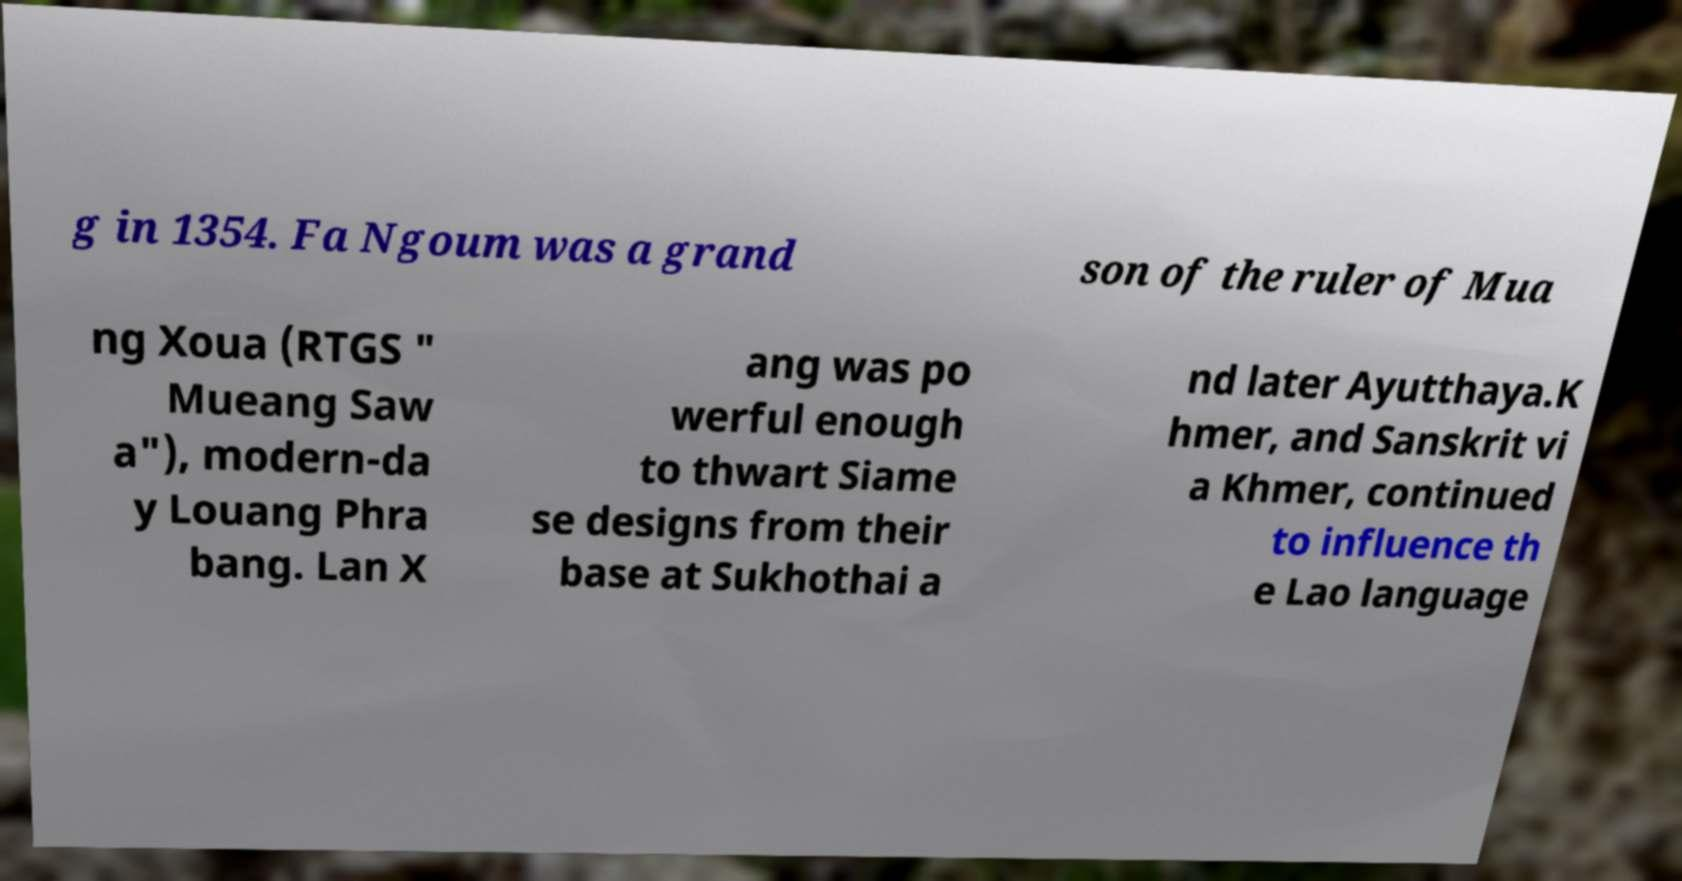Could you extract and type out the text from this image? g in 1354. Fa Ngoum was a grand son of the ruler of Mua ng Xoua (RTGS " Mueang Saw a"), modern-da y Louang Phra bang. Lan X ang was po werful enough to thwart Siame se designs from their base at Sukhothai a nd later Ayutthaya.K hmer, and Sanskrit vi a Khmer, continued to influence th e Lao language 